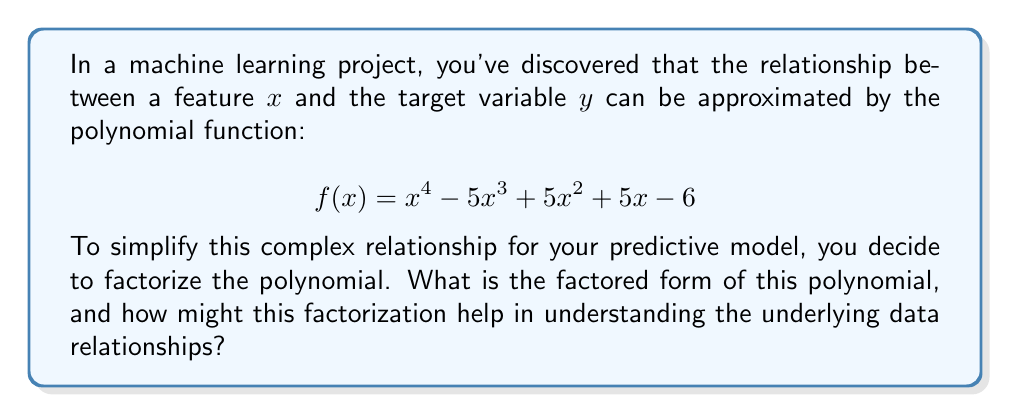Provide a solution to this math problem. To factorize this polynomial, we'll follow these steps:

1) First, let's check if there are any common factors. In this case, there are none.

2) Next, we'll try to find the factors using the rational root theorem. The possible rational roots are the factors of the constant term: ±1, ±2, ±3, ±6.

3) Testing these values, we find that $f(1) = 0$ and $f(2) = 0$. So $(x-1)$ and $(x-2)$ are factors.

4) Dividing $f(x)$ by $(x-1)(x-2)$, we get:

   $$f(x) = (x-1)(x-2)(x^2 - 2x - 3)$$

5) The quadratic factor $x^2 - 2x - 3$ can be further factored:

   $$x^2 - 2x - 3 = (x-3)(x+1)$$

6) Therefore, the fully factored form is:

   $$f(x) = (x-1)(x-2)(x-3)(x+1)$$

This factorization helps in understanding the data relationships in several ways:

1) It reveals the roots of the polynomial: $x = 1$, $x = 2$, $x = 3$, and $x = -1$. These are the points where the function crosses the x-axis, which could represent critical thresholds in your data.

2) The linear factors $(x-1)$, $(x-2)$, $(x-3)$, and $(x+1)$ show how the relationship between $x$ and $y$ can be broken down into simpler, more interpretable components.

3) This factored form makes it easier to analyze the behavior of the function near these critical points, which could be valuable for feature engineering or understanding edge cases in your model.

4) The factorization simplifies the calculation of derivatives, which could be useful for gradient-based optimization techniques in your machine learning algorithms.
Answer: The factored form of the polynomial is:

$$(x-1)(x-2)(x-3)(x+1)$$

This factorization reveals the roots of the polynomial and breaks down the complex relationship into simpler, interpretable components, which can aid in feature engineering, understanding critical thresholds, and optimizing machine learning algorithms. 